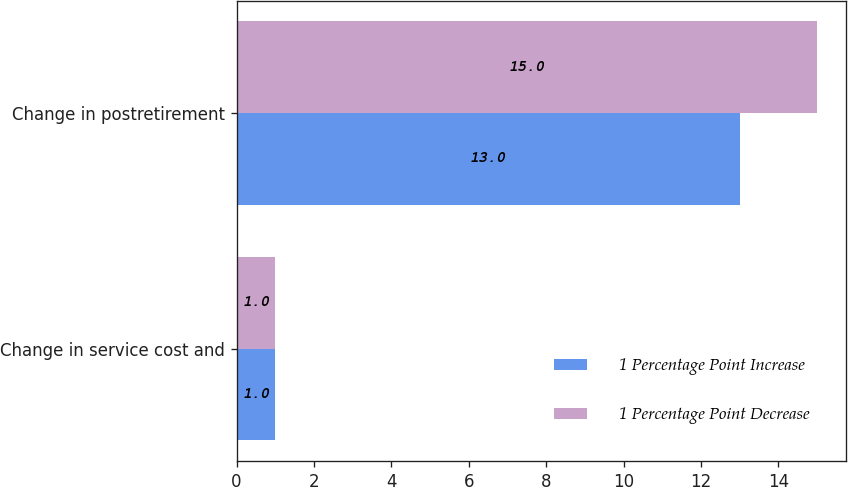<chart> <loc_0><loc_0><loc_500><loc_500><stacked_bar_chart><ecel><fcel>Change in service cost and<fcel>Change in postretirement<nl><fcel>1 Percentage Point Increase<fcel>1<fcel>13<nl><fcel>1 Percentage Point Decrease<fcel>1<fcel>15<nl></chart> 